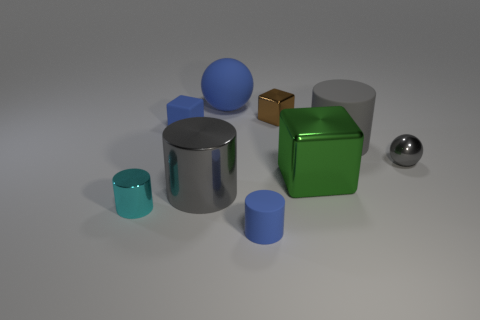What time of day or lighting conditions does the image suggest? The lighting in the image is soft and diffused, with subtle shadows suggesting an indoor setting with ambient lighting, possibly during daytime with indirect sunlight. 